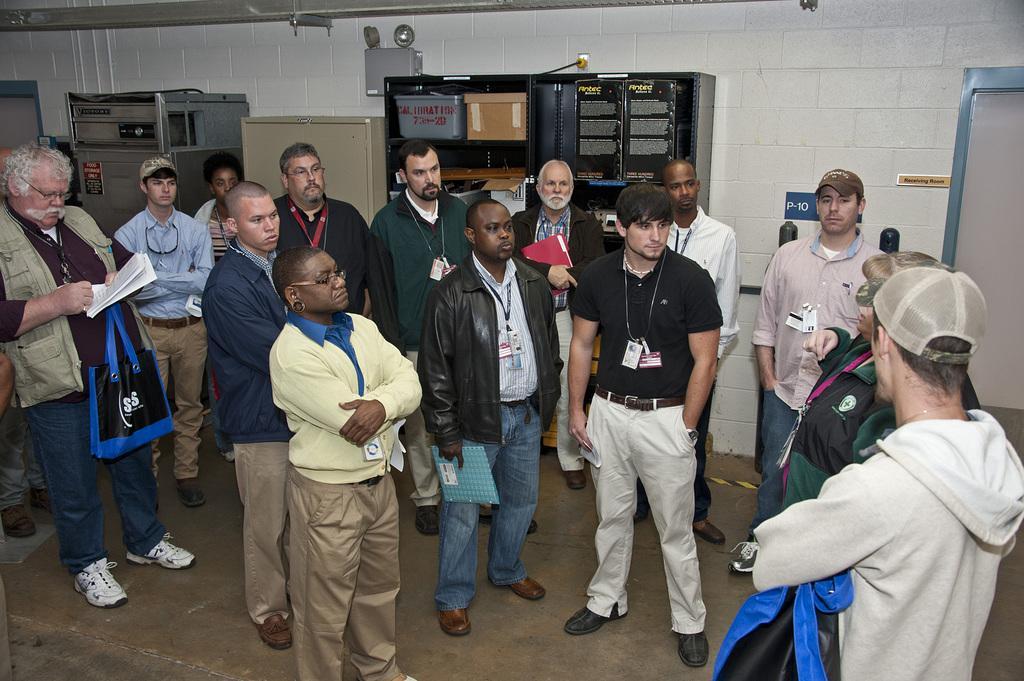In one or two sentences, can you explain what this image depicts? In this image, we can see some people standing, at the background there is a black color rack and there is a white color wall. 